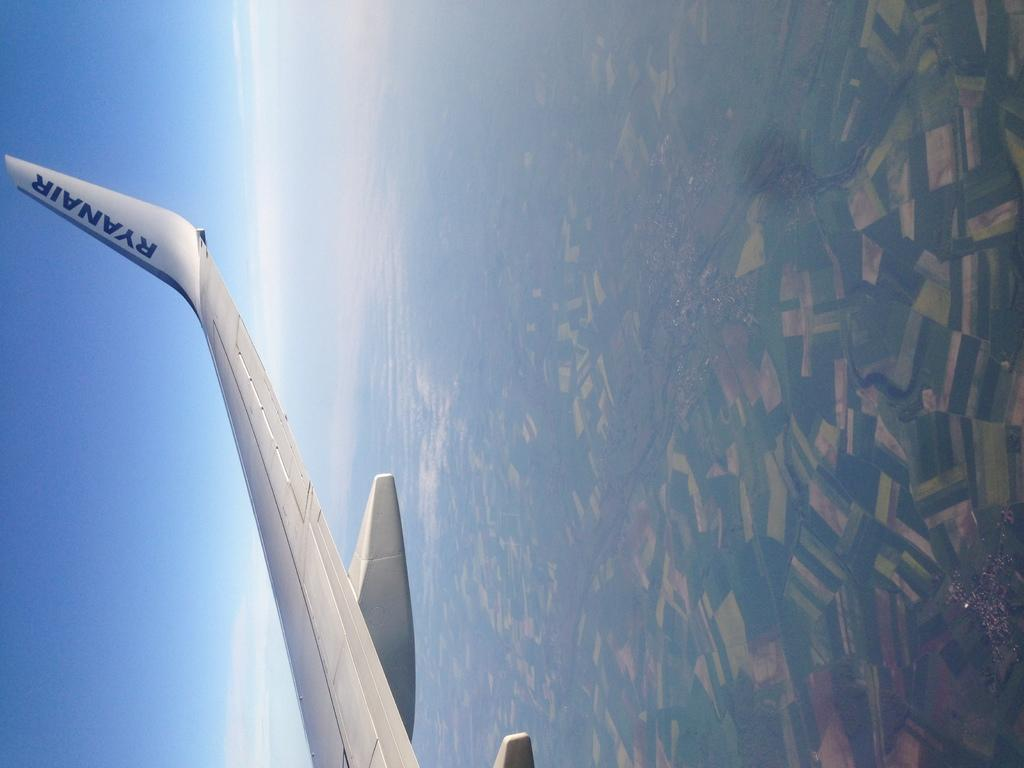Provide a one-sentence caption for the provided image. Ryanair wrote in blue on a white airplane in the sky. 